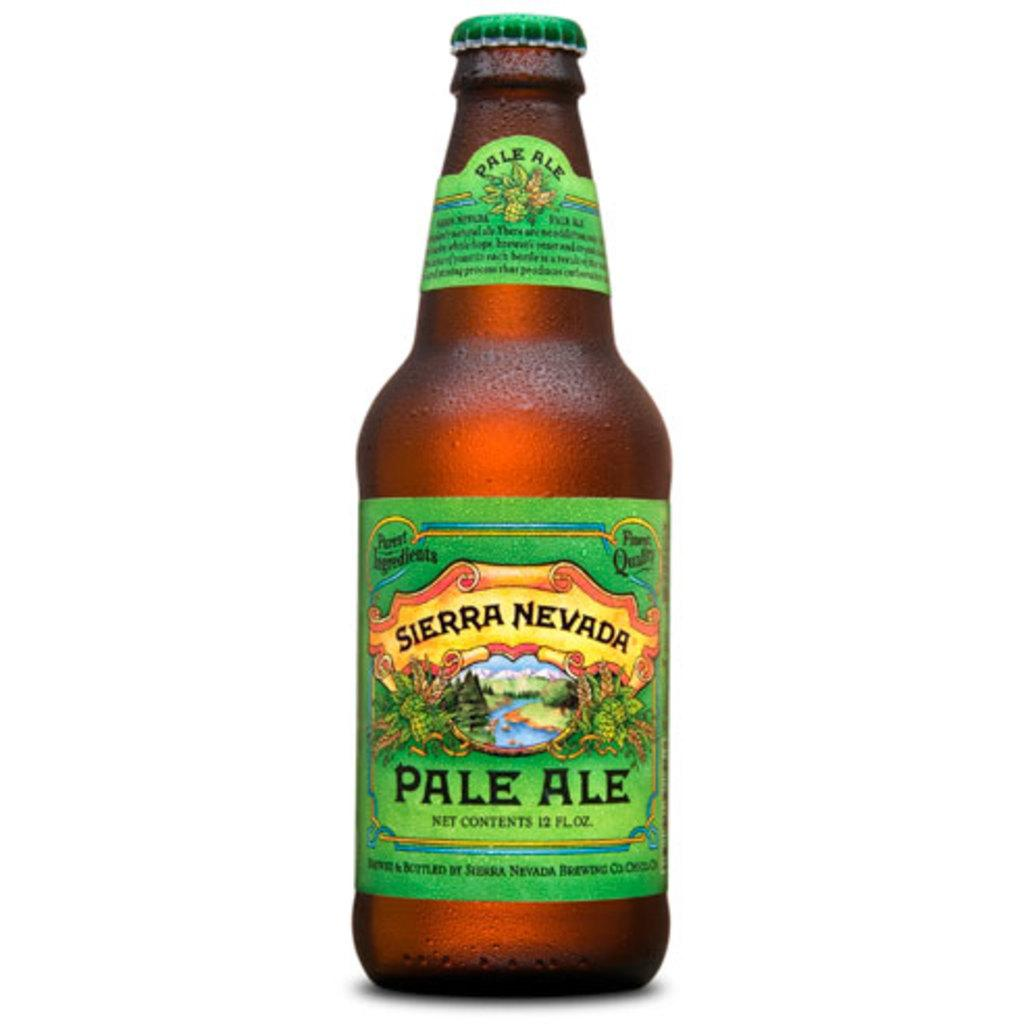Provide a one-sentence caption for the provided image. An unopened bottle of Sierra Nevada Pale Ale has a bright green label, with an image of a river flowing through a valley. 